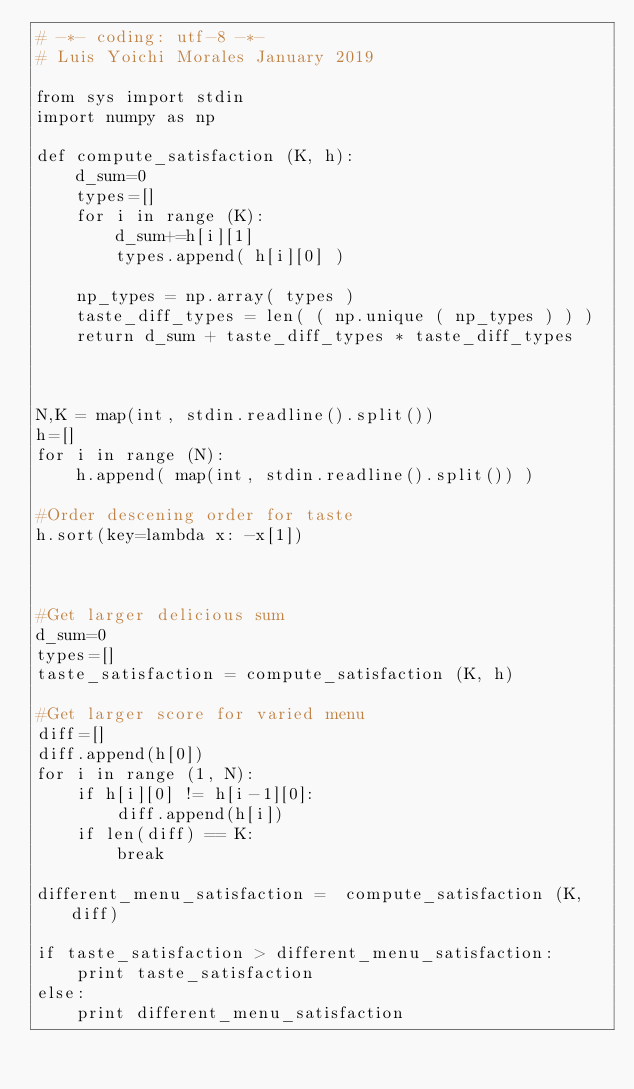Convert code to text. <code><loc_0><loc_0><loc_500><loc_500><_Python_># -*- coding: utf-8 -*-
# Luis Yoichi Morales January 2019

from sys import stdin
import numpy as np

def compute_satisfaction (K, h):
    d_sum=0
    types=[]
    for i in range (K):
        d_sum+=h[i][1]
        types.append( h[i][0] )

    np_types = np.array( types )
    taste_diff_types = len( ( np.unique ( np_types ) ) )
    return d_sum + taste_diff_types * taste_diff_types



N,K = map(int, stdin.readline().split())
h=[]
for i in range (N):
    h.append( map(int, stdin.readline().split()) )

#Order descening order for taste
h.sort(key=lambda x: -x[1])



#Get larger delicious sum
d_sum=0
types=[]
taste_satisfaction = compute_satisfaction (K, h) 

#Get larger score for varied menu
diff=[]
diff.append(h[0])
for i in range (1, N):
    if h[i][0] != h[i-1][0]:
        diff.append(h[i])
    if len(diff) == K:
        break

different_menu_satisfaction =  compute_satisfaction (K, diff)

if taste_satisfaction > different_menu_satisfaction:
    print taste_satisfaction
else:
    print different_menu_satisfaction

</code> 